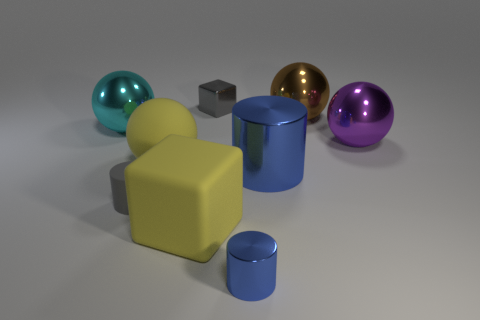What could be the purpose of these various objects? Given their simplistic geometric shapes and the pristine condition, these objects likely serve an illustrative or educational purpose. They could be used to teach principles of geometry, shading, and color in a graphic design or a 3D modeling class. How do you think the lighting affects the appearance of the objects? The lighting plays a significant role in highlighting the textures and colors of the objects. It casts soft shadows and emphasizes the glossiness of the metallic surfaces, while also defining the form of the objects by creating gradients and contrasts. 